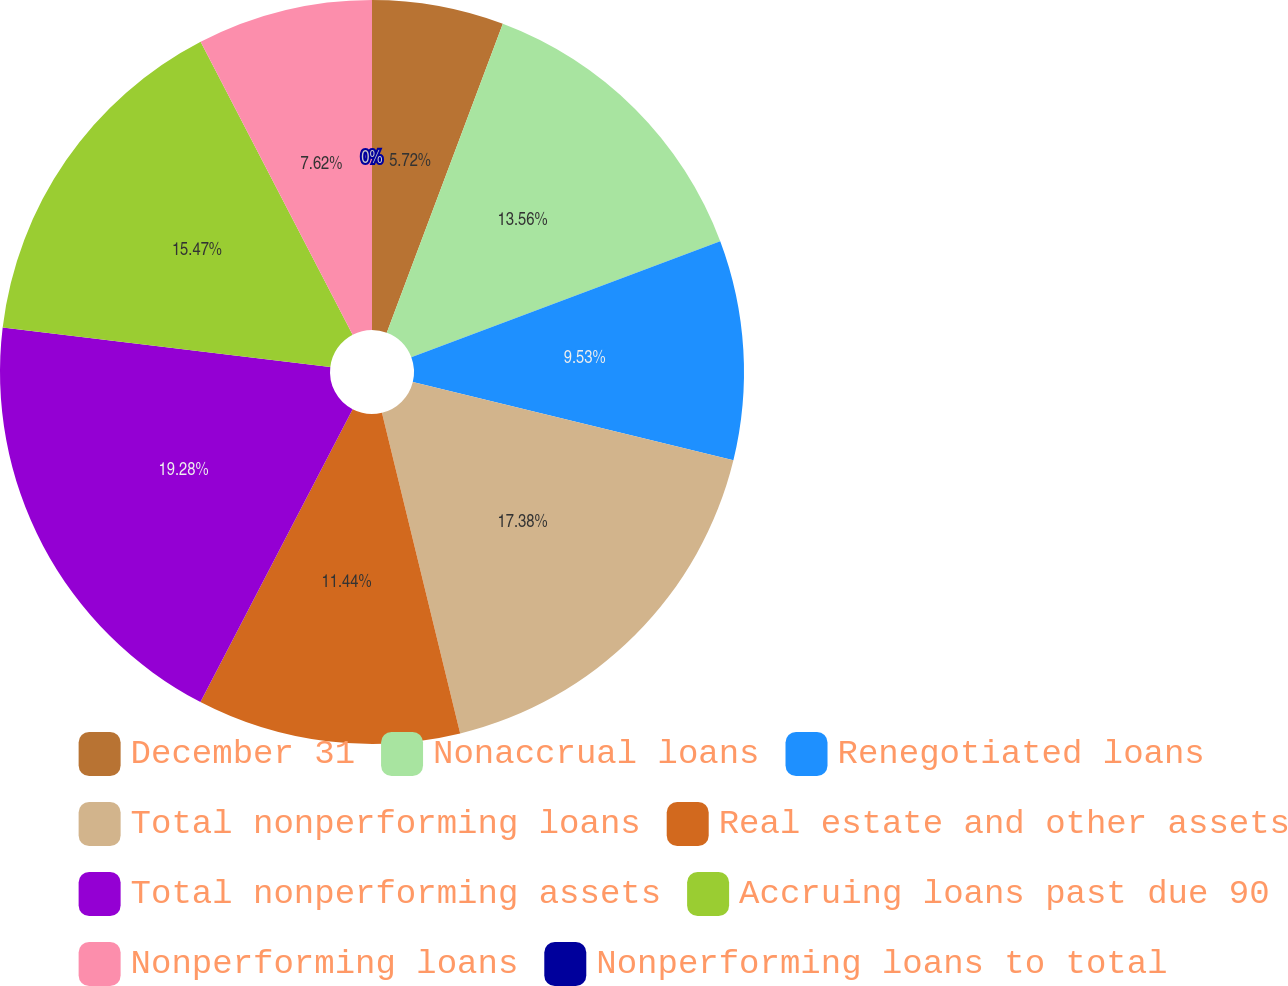<chart> <loc_0><loc_0><loc_500><loc_500><pie_chart><fcel>December 31<fcel>Nonaccrual loans<fcel>Renegotiated loans<fcel>Total nonperforming loans<fcel>Real estate and other assets<fcel>Total nonperforming assets<fcel>Accruing loans past due 90<fcel>Nonperforming loans<fcel>Nonperforming loans to total<nl><fcel>5.72%<fcel>13.56%<fcel>9.53%<fcel>17.38%<fcel>11.44%<fcel>19.28%<fcel>15.47%<fcel>7.62%<fcel>0.0%<nl></chart> 